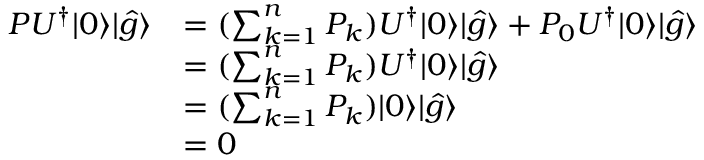Convert formula to latex. <formula><loc_0><loc_0><loc_500><loc_500>\begin{array} { r l } { P U ^ { \dagger } | 0 \rangle | \hat { g } \rangle } & { = ( \sum _ { k = 1 } ^ { n } P _ { k } ) U ^ { \dagger } | 0 \rangle | \hat { g } \rangle + P _ { 0 } U ^ { \dagger } | 0 \rangle | \hat { g } \rangle } \\ & { = ( \sum _ { k = 1 } ^ { n } P _ { k } ) U ^ { \dagger } | 0 \rangle | \hat { g } \rangle } \\ & { = ( \sum _ { k = 1 } ^ { n } P _ { k } ) | 0 \rangle | \hat { g } \rangle } \\ & { = 0 } \end{array}</formula> 